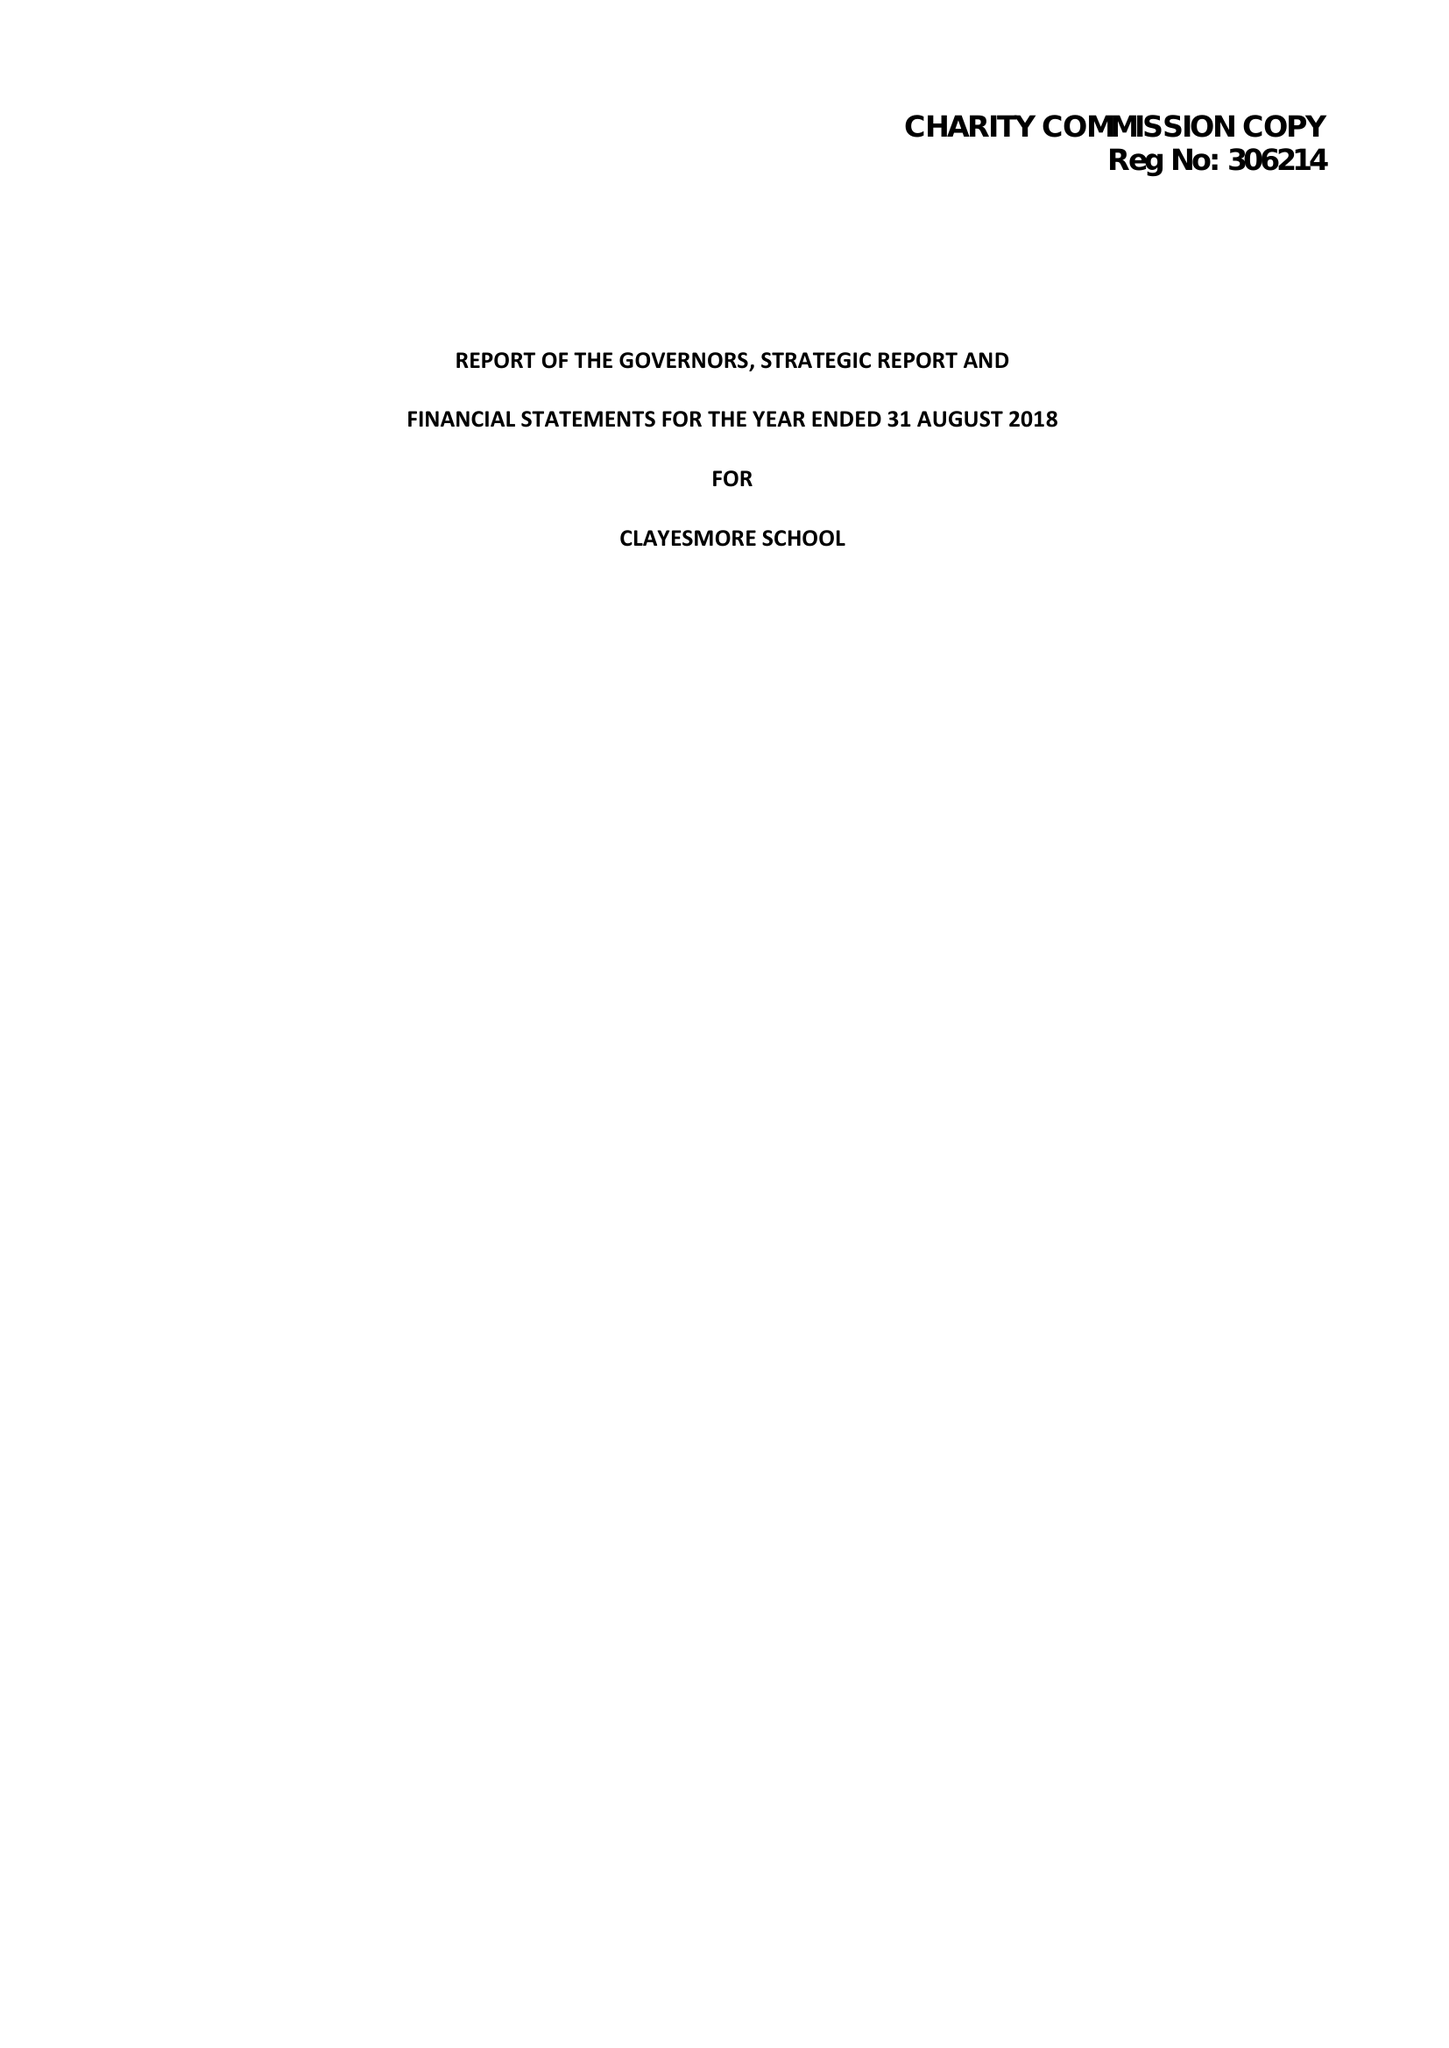What is the value for the spending_annually_in_british_pounds?
Answer the question using a single word or phrase. 14335233.00 